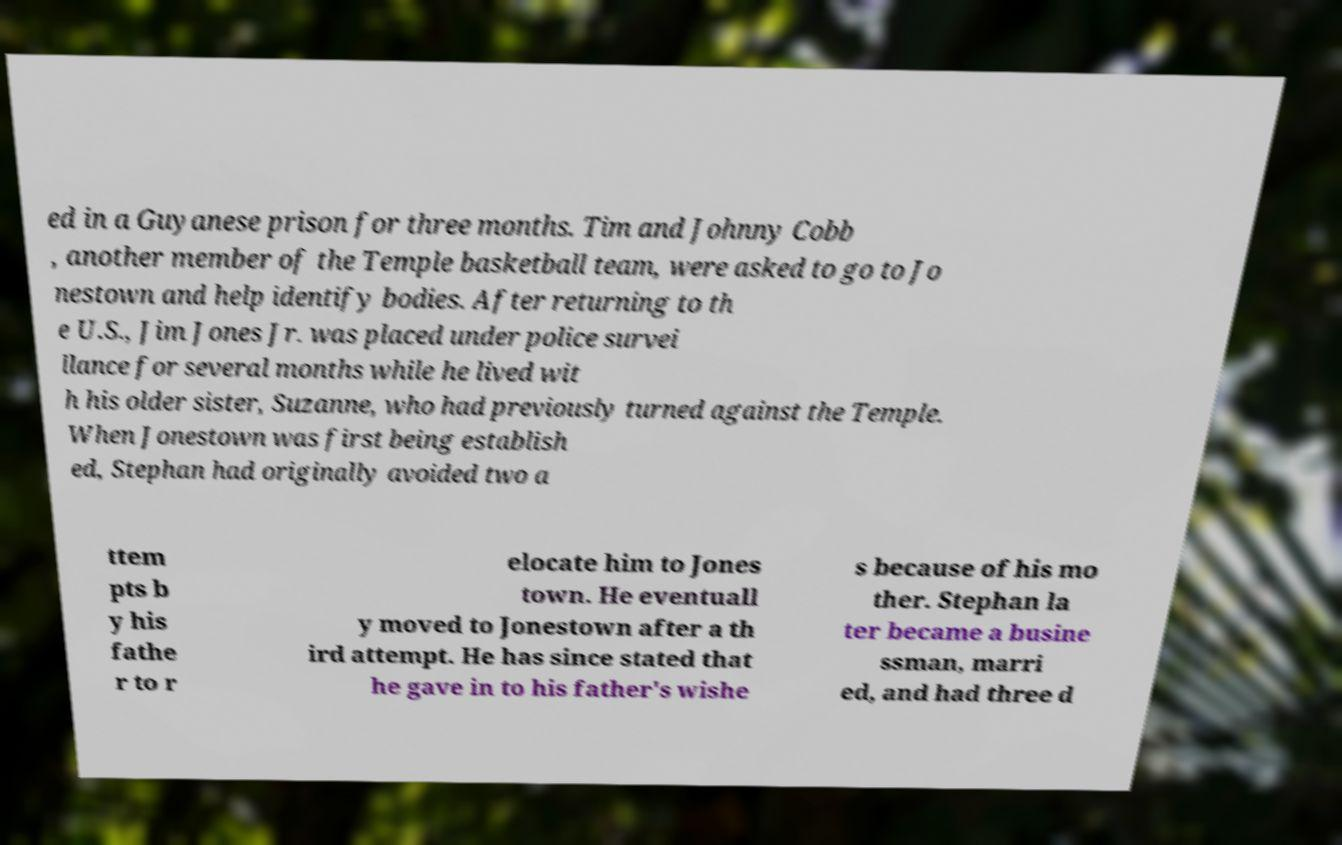Please read and relay the text visible in this image. What does it say? ed in a Guyanese prison for three months. Tim and Johnny Cobb , another member of the Temple basketball team, were asked to go to Jo nestown and help identify bodies. After returning to th e U.S., Jim Jones Jr. was placed under police survei llance for several months while he lived wit h his older sister, Suzanne, who had previously turned against the Temple. When Jonestown was first being establish ed, Stephan had originally avoided two a ttem pts b y his fathe r to r elocate him to Jones town. He eventuall y moved to Jonestown after a th ird attempt. He has since stated that he gave in to his father's wishe s because of his mo ther. Stephan la ter became a busine ssman, marri ed, and had three d 